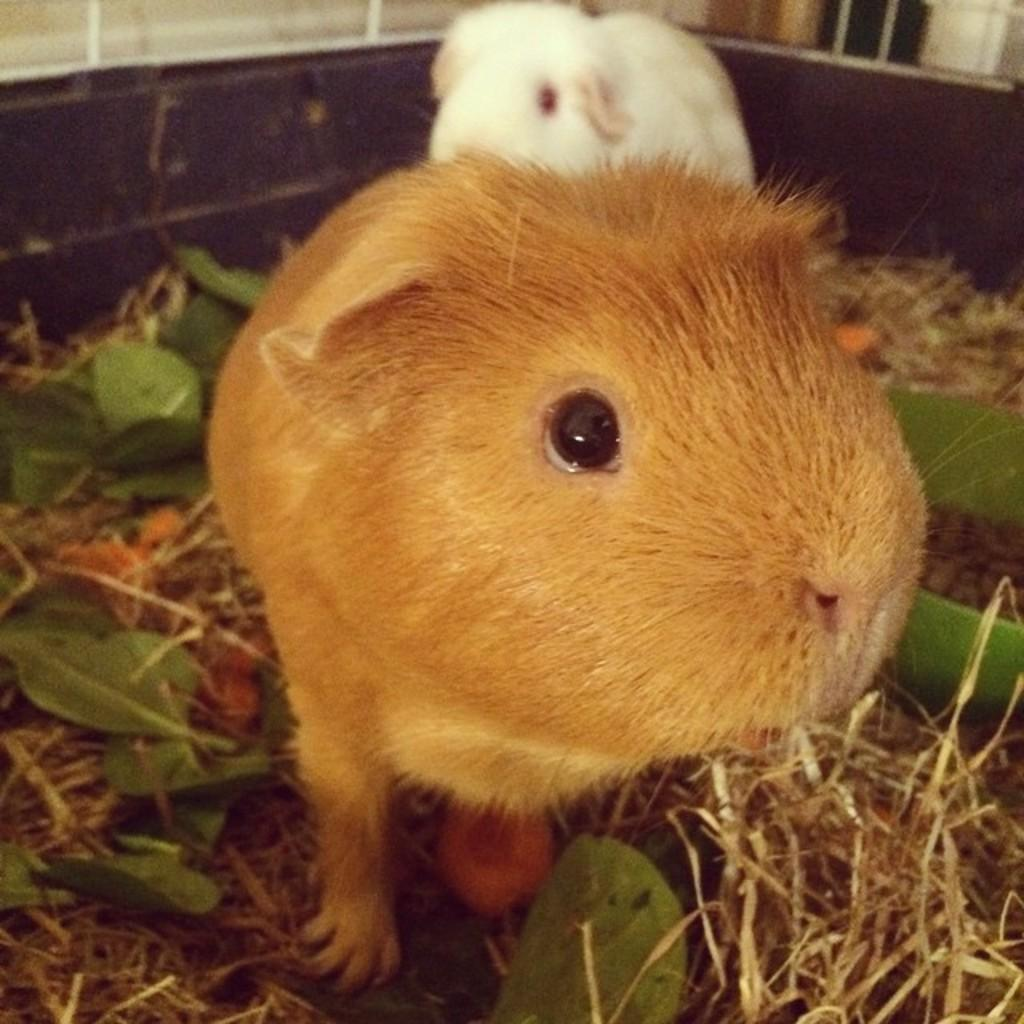What type of animals can be seen in the image? There is a brown animal and a white animal in the image. Where are the animals located? Both animals are on the grass in the image. What color are the leaves visible in the image? The leaves are green in the image. What decision is the knife making in the image? There is no knife present in the image, so it cannot make any decisions. 